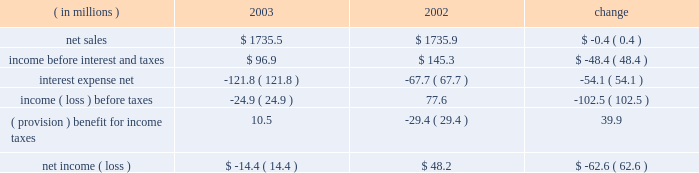Other expense , net , decreased $ 6.2 million , or 50.0% ( 50.0 % ) , for the year ended december 31 , 2004 compared to the year ended december 31 , 2003 .
The decrease was primarily due to a reduction in charges on disposal and transfer costs of fixed assets and facility closure costs of $ 3.3 million , reduced legal charges of $ 1.5 million , and a reduction in expenses of $ 1.4 million consisting of individually insignificant items .
Interest expense and income taxes interest expense decreased in 2004 by $ 92.2 million , or 75.7% ( 75.7 % ) , from 2003 .
This decrease included $ 73.3 million of expenses related to the company 2019s debt refinancing , which was completed in july 2003 .
The $ 73.3 million of expenses consisted of $ 55.9 million paid in premiums for the tender of the 95 20448% ( 20448 % ) senior subordinated notes , and a $ 17.4 million non-cash charge for the write-off of deferred financing fees related to the 95 20448% ( 20448 % ) notes and pca 2019s original revolving credit facility .
Excluding the $ 73.3 million charge , interest expense was $ 18.9 million lower than in 2003 as a result of lower interest rates attributable to the company 2019s july 2003 refinancing and lower debt levels .
Pca 2019s effective tax rate was 38.0% ( 38.0 % ) for the year ended december 31 , 2004 and 42.3% ( 42.3 % ) for the year ended december 31 , 2003 .
The higher tax rate in 2003 is due to stable permanent items over lower book income ( loss ) .
For both years 2004 and 2003 tax rates are higher than the federal statutory rate of 35.0% ( 35.0 % ) due to state income taxes .
Year ended december 31 , 2003 compared to year ended december 31 , 2002 the historical results of operations of pca for the years ended december 31 , 2003 and 2002 are set forth below : for the year ended december 31 , ( in millions ) 2003 2002 change .
Net sales net sales decreased by $ 0.4 million , or 0.0% ( 0.0 % ) , for the year ended december 31 , 2003 from the year ended december 31 , 2002 .
Net sales increased due to improved sales volumes compared to 2002 , however , this increase was entirely offset by lower sales prices .
Total corrugated products volume sold increased 2.1% ( 2.1 % ) to 28.1 billion square feet in 2003 compared to 27.5 billion square feet in 2002 .
On a comparable shipment-per-workday basis , corrugated products sales volume increased 1.7% ( 1.7 % ) in 2003 from 2002 .
Shipments-per-workday is calculated by dividing our total corrugated products volume during the year by the number of workdays within the year .
The lower percentage increase was due to the fact that 2003 had one more workday ( 252 days ) , those days not falling on a weekend or holiday , than 2002 ( 251 days ) .
Containerboard sales volume to external domestic and export customers decreased 6.7% ( 6.7 % ) to 445000 tons for the year ended december 31 , 2003 from 477000 tons in the comparable period of 2002 .
Income before interest and taxes income before interest and taxes decreased by $ 48.4 million , or 33.3% ( 33.3 % ) , for the year ended december 31 , 2003 compared to 2002 .
Included in income before interest and taxes for the twelve months .
What was the operating margin for 2002? 
Computations: (145.3 / 1735.9)
Answer: 0.0837. 